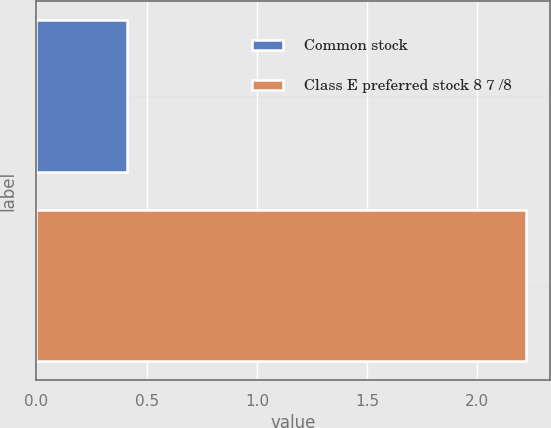<chart> <loc_0><loc_0><loc_500><loc_500><bar_chart><fcel>Common stock<fcel>Class E preferred stock 8 7 /8<nl><fcel>0.41<fcel>2.22<nl></chart> 